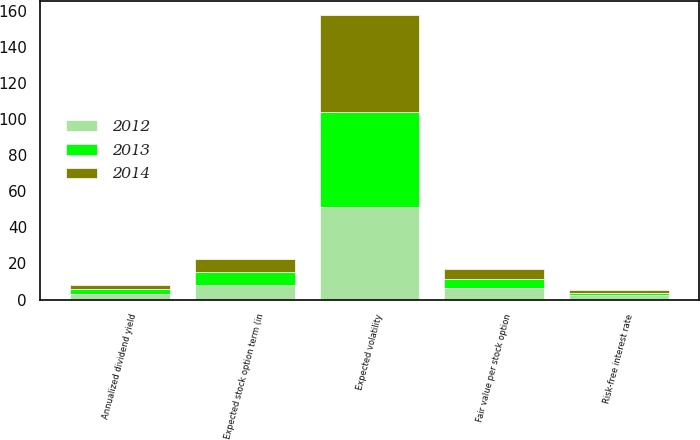<chart> <loc_0><loc_0><loc_500><loc_500><stacked_bar_chart><ecel><fcel>Fair value per stock option<fcel>Annualized dividend yield<fcel>Expected volatility<fcel>Risk-free interest rate<fcel>Expected stock option term (in<nl><fcel>2012<fcel>6.21<fcel>3<fcel>51.5<fcel>2.4<fcel>7.8<nl><fcel>2013<fcel>5.03<fcel>3<fcel>52.2<fcel>1.5<fcel>7.7<nl><fcel>2014<fcel>5.88<fcel>2<fcel>53.8<fcel>1.6<fcel>7.2<nl></chart> 